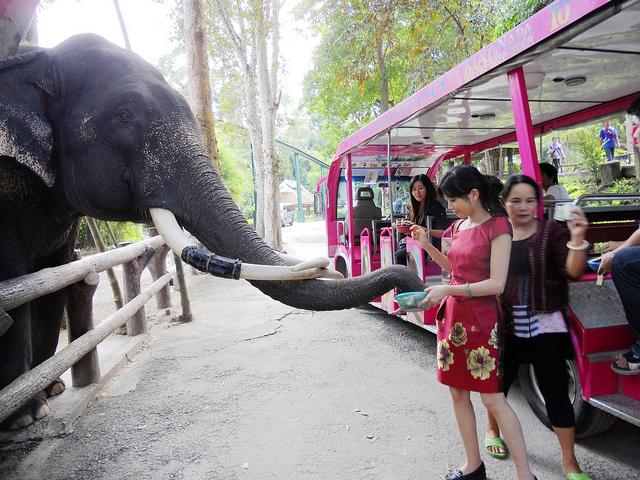What does the elephant seek? food 